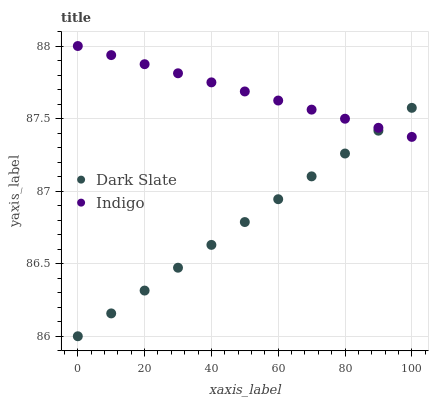Does Dark Slate have the minimum area under the curve?
Answer yes or no. Yes. Does Indigo have the maximum area under the curve?
Answer yes or no. Yes. Does Indigo have the minimum area under the curve?
Answer yes or no. No. Is Dark Slate the smoothest?
Answer yes or no. Yes. Is Indigo the roughest?
Answer yes or no. Yes. Is Indigo the smoothest?
Answer yes or no. No. Does Dark Slate have the lowest value?
Answer yes or no. Yes. Does Indigo have the lowest value?
Answer yes or no. No. Does Indigo have the highest value?
Answer yes or no. Yes. Does Indigo intersect Dark Slate?
Answer yes or no. Yes. Is Indigo less than Dark Slate?
Answer yes or no. No. Is Indigo greater than Dark Slate?
Answer yes or no. No. 